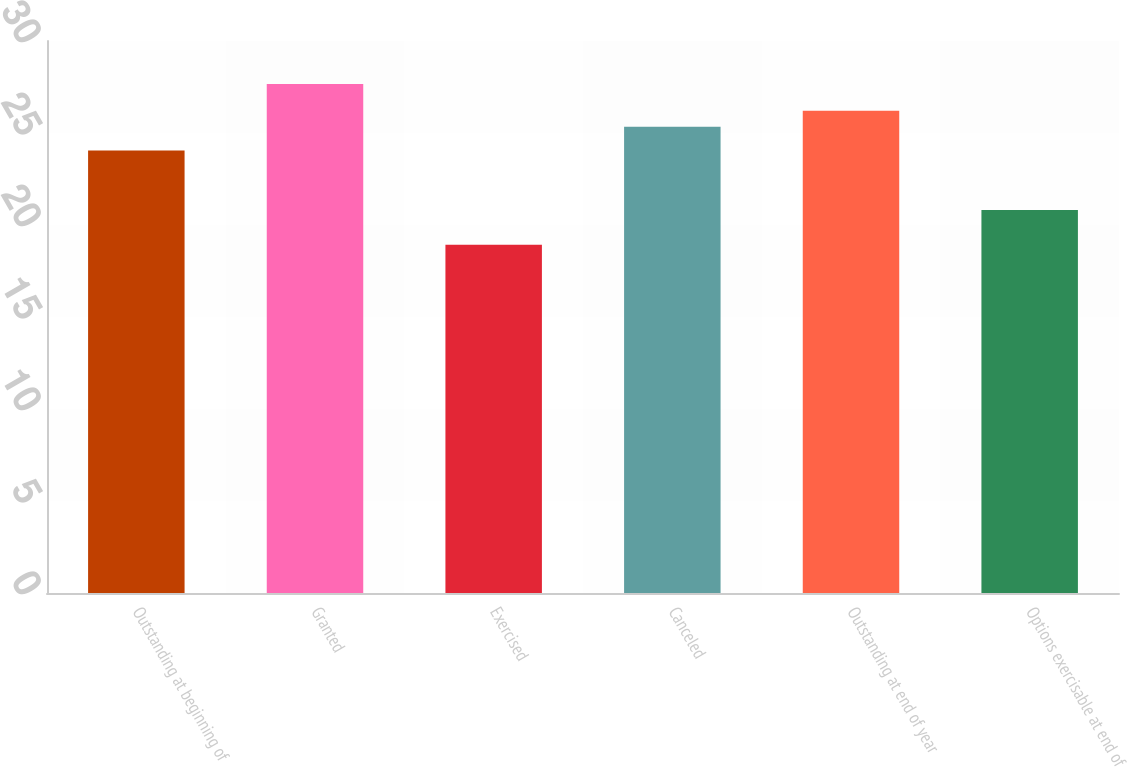Convert chart. <chart><loc_0><loc_0><loc_500><loc_500><bar_chart><fcel>Outstanding at beginning of<fcel>Granted<fcel>Exercised<fcel>Canceled<fcel>Outstanding at end of year<fcel>Options exercisable at end of<nl><fcel>24.05<fcel>27.66<fcel>18.92<fcel>25.34<fcel>26.21<fcel>20.81<nl></chart> 